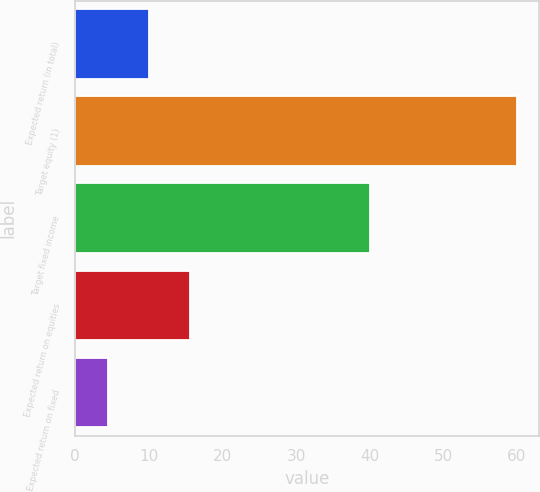<chart> <loc_0><loc_0><loc_500><loc_500><bar_chart><fcel>Expected return (in total)<fcel>Target equity (1)<fcel>Target fixed income<fcel>Expected return on equities<fcel>Expected return on fixed<nl><fcel>10.05<fcel>60<fcel>40<fcel>15.6<fcel>4.5<nl></chart> 